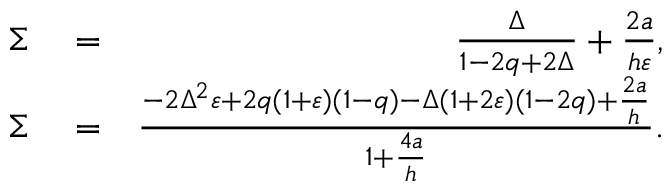<formula> <loc_0><loc_0><loc_500><loc_500>\begin{array} { r l r } { \Sigma } & = } & { \frac { \Delta } { 1 - 2 q + 2 \Delta } + \frac { 2 a } { h \varepsilon } , } \\ { \Sigma } & = } & { \frac { - 2 \Delta ^ { 2 } \varepsilon + 2 q ( 1 + \varepsilon ) ( 1 - q ) - \Delta ( 1 + 2 \varepsilon ) ( 1 - 2 q ) + \frac { 2 a } { h } } { 1 + \frac { 4 a } { h } } . } \end{array}</formula> 